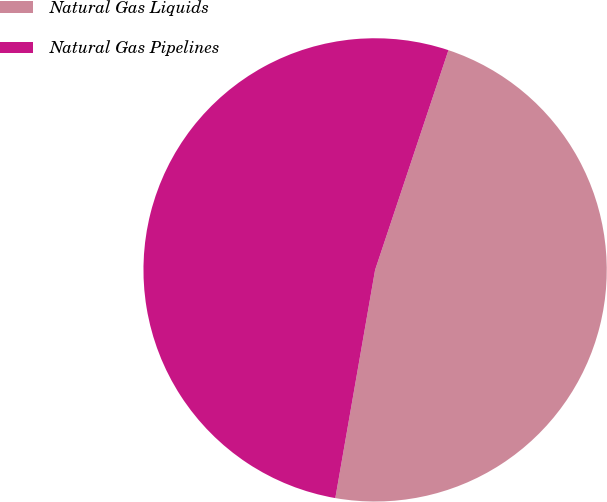Convert chart. <chart><loc_0><loc_0><loc_500><loc_500><pie_chart><fcel>Natural Gas Liquids<fcel>Natural Gas Pipelines<nl><fcel>47.62%<fcel>52.38%<nl></chart> 